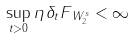Convert formula to latex. <formula><loc_0><loc_0><loc_500><loc_500>\sup _ { t > 0 } \| \eta \, \delta _ { t } F \| _ { W _ { 2 } ^ { s } } < \infty</formula> 